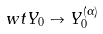Convert formula to latex. <formula><loc_0><loc_0><loc_500><loc_500>\ w t { Y } _ { 0 } \to Y _ { 0 } ^ { ( \alpha ) }</formula> 